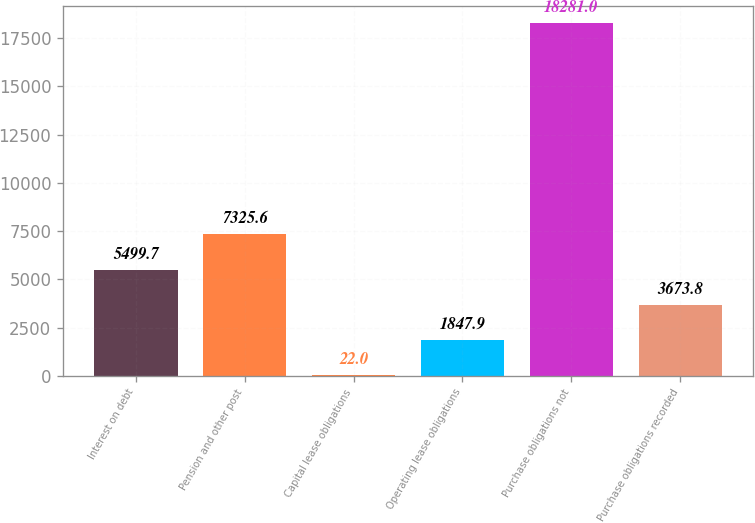Convert chart to OTSL. <chart><loc_0><loc_0><loc_500><loc_500><bar_chart><fcel>Interest on debt<fcel>Pension and other post<fcel>Capital lease obligations<fcel>Operating lease obligations<fcel>Purchase obligations not<fcel>Purchase obligations recorded<nl><fcel>5499.7<fcel>7325.6<fcel>22<fcel>1847.9<fcel>18281<fcel>3673.8<nl></chart> 